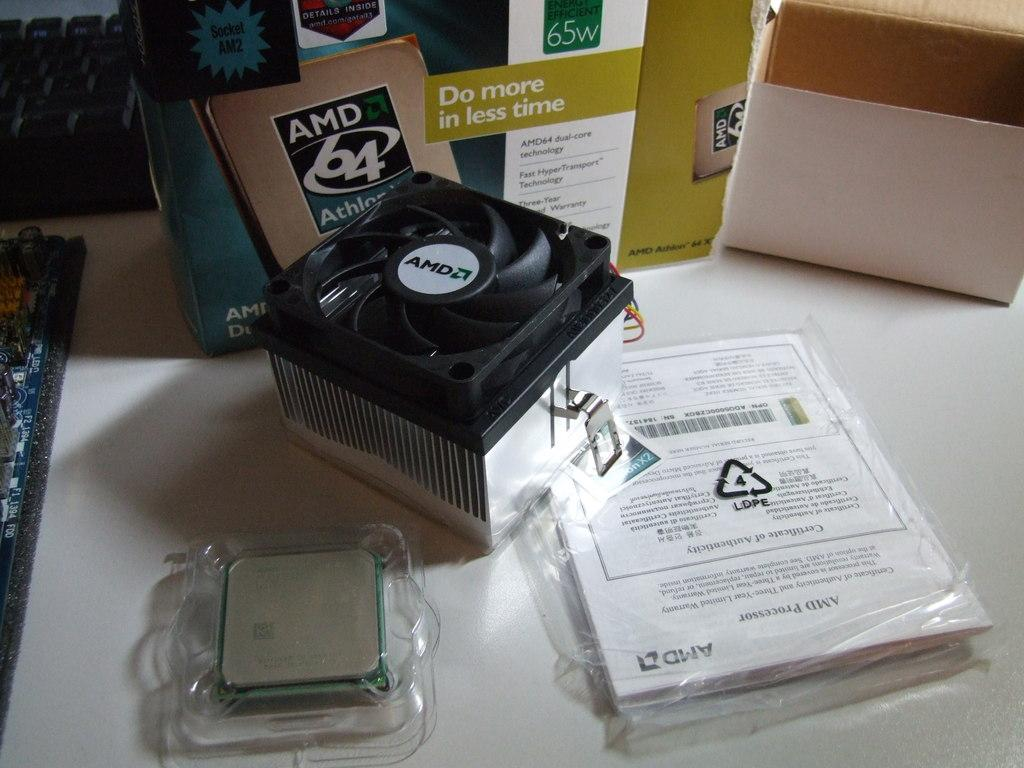<image>
Give a short and clear explanation of the subsequent image. Computer part next to a box that says AMD64. 